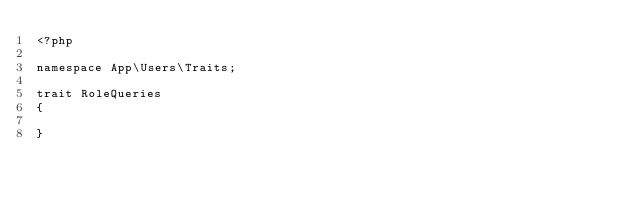<code> <loc_0><loc_0><loc_500><loc_500><_PHP_><?php

namespace App\Users\Traits;

trait RoleQueries
{

}</code> 